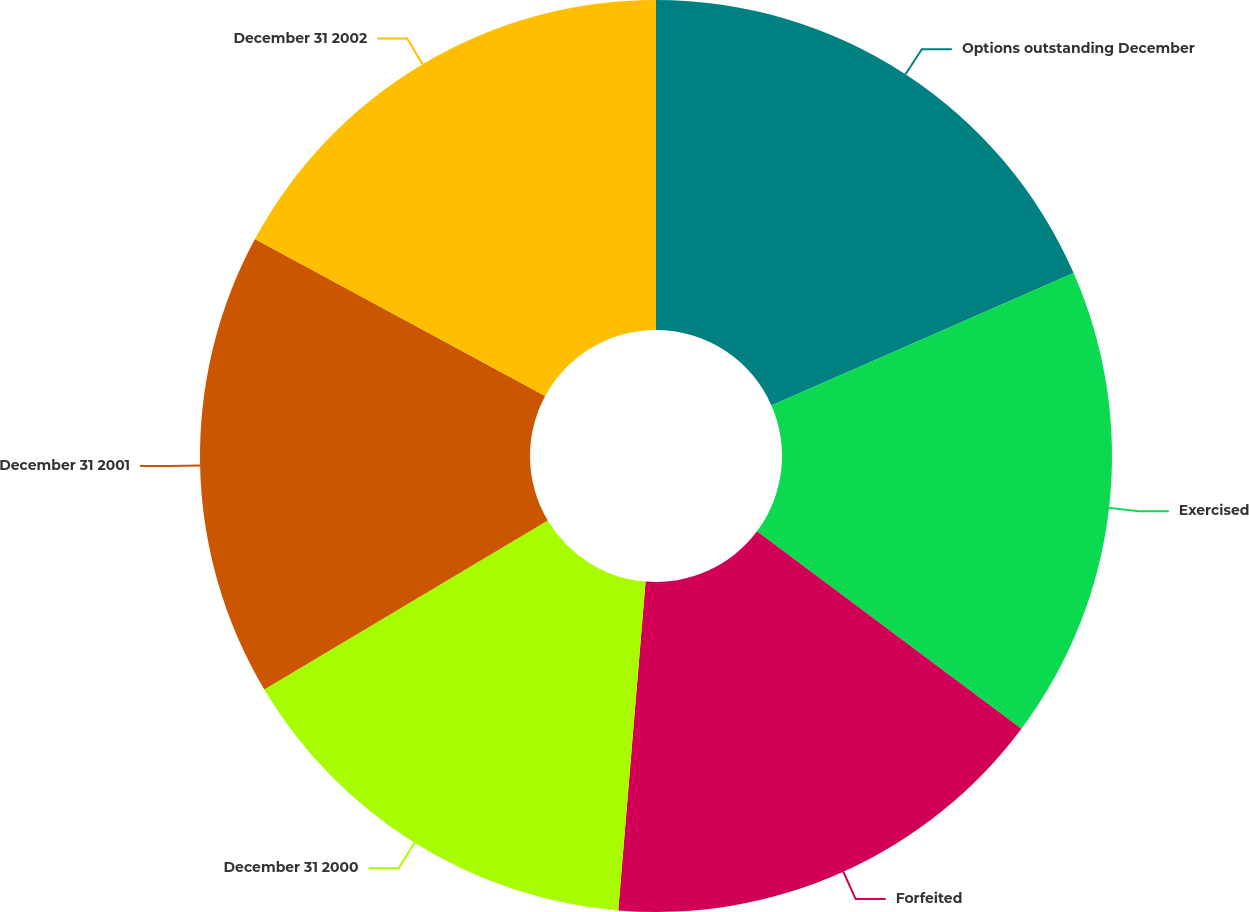<chart> <loc_0><loc_0><loc_500><loc_500><pie_chart><fcel>Options outstanding December<fcel>Exercised<fcel>Forfeited<fcel>December 31 2000<fcel>December 31 2001<fcel>December 31 2002<nl><fcel>18.43%<fcel>16.78%<fcel>16.12%<fcel>15.13%<fcel>16.45%<fcel>17.11%<nl></chart> 